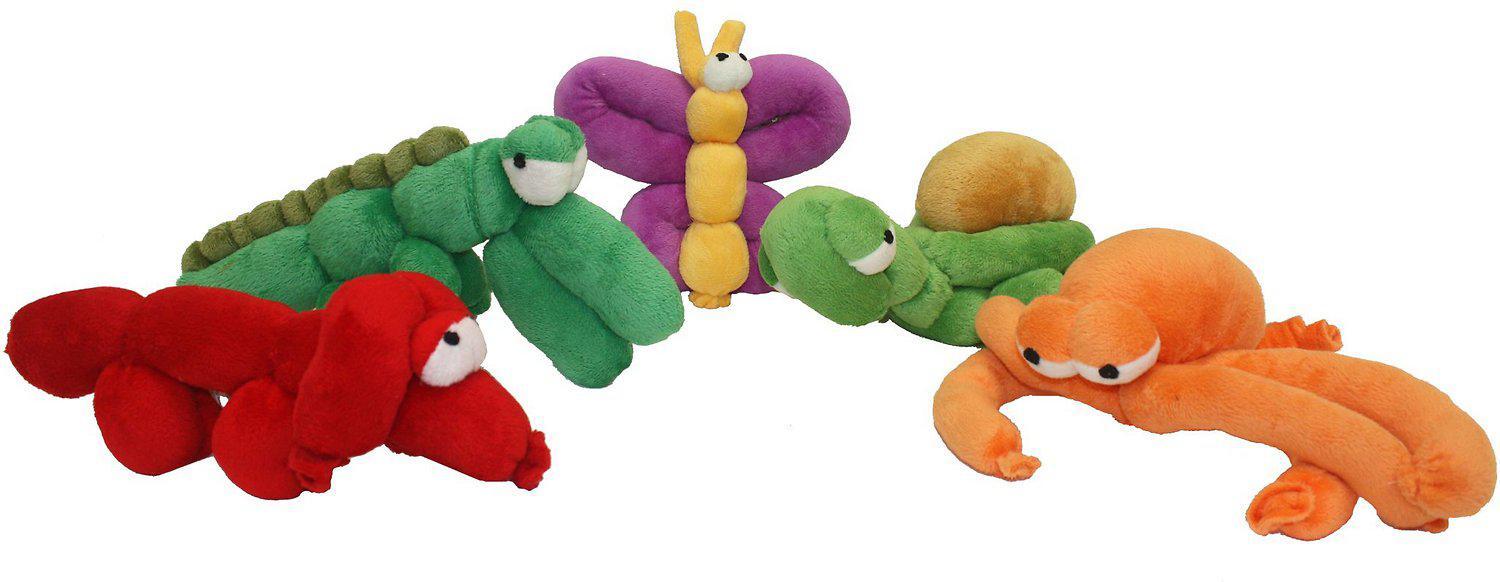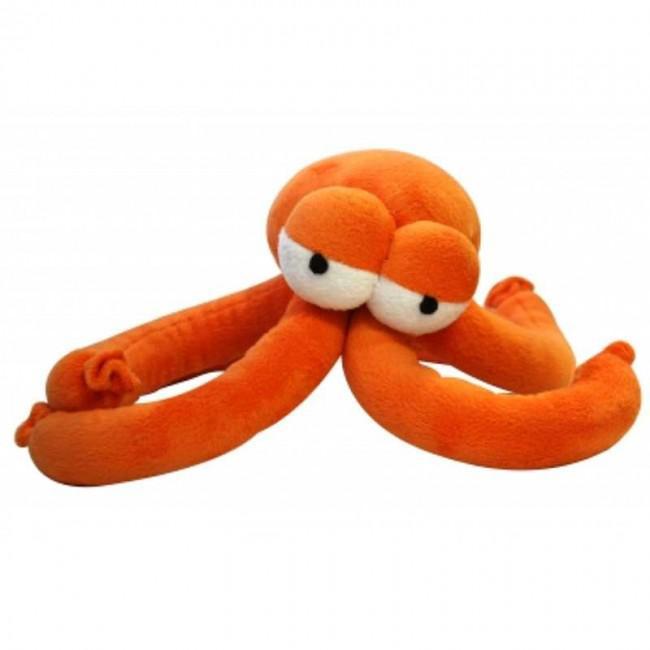The first image is the image on the left, the second image is the image on the right. Assess this claim about the two images: "One of the balloons is the shape of a lion.". Correct or not? Answer yes or no. No. 